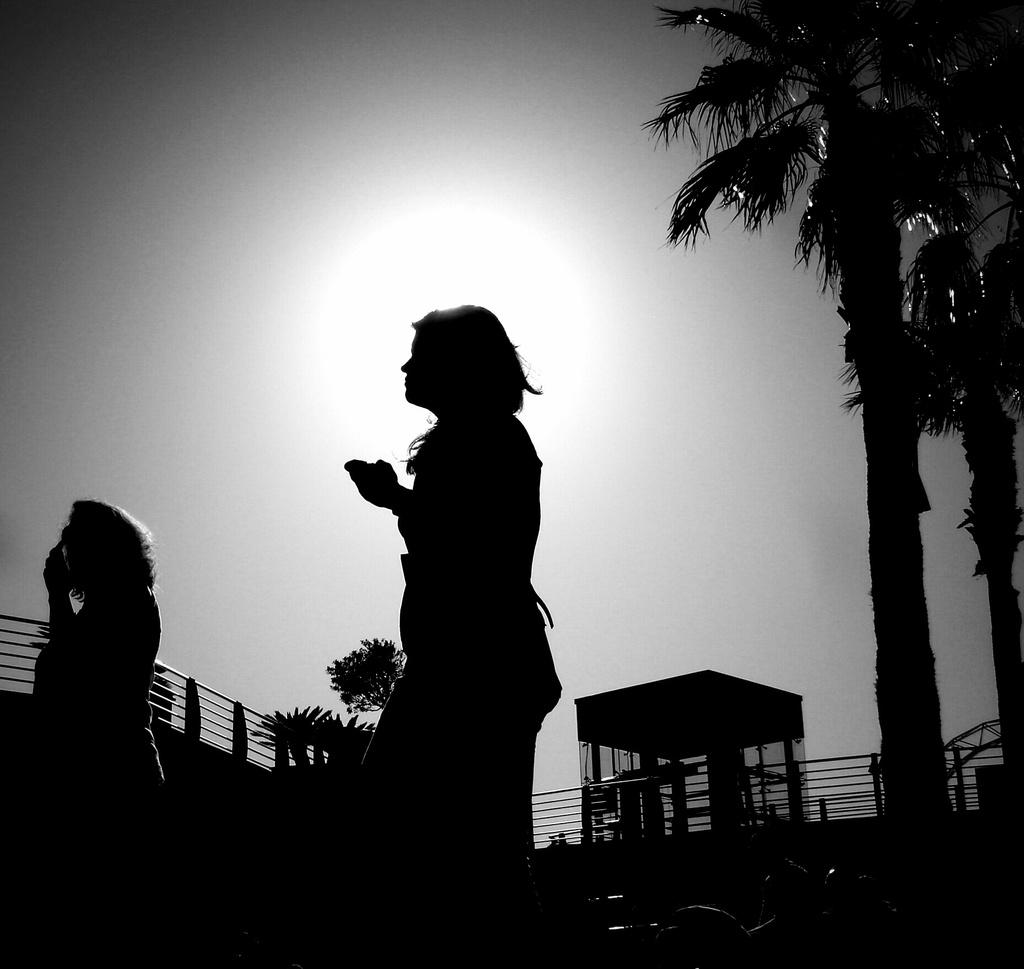What is the overall lighting condition in the image? The image is dark. How many people are present in the image? There are two persons in the image. What type of vegetation is on the right side of the image? There are trees on the right side of the image. What is visible at the top of the image? The sky is visible at the top of the image. What type of rule is being enforced by the judge in the image? There is no judge or rule present in the image; it features two persons and trees. How many dolls are sitting on the bench in the image? There are no dolls or benches present in the image. 